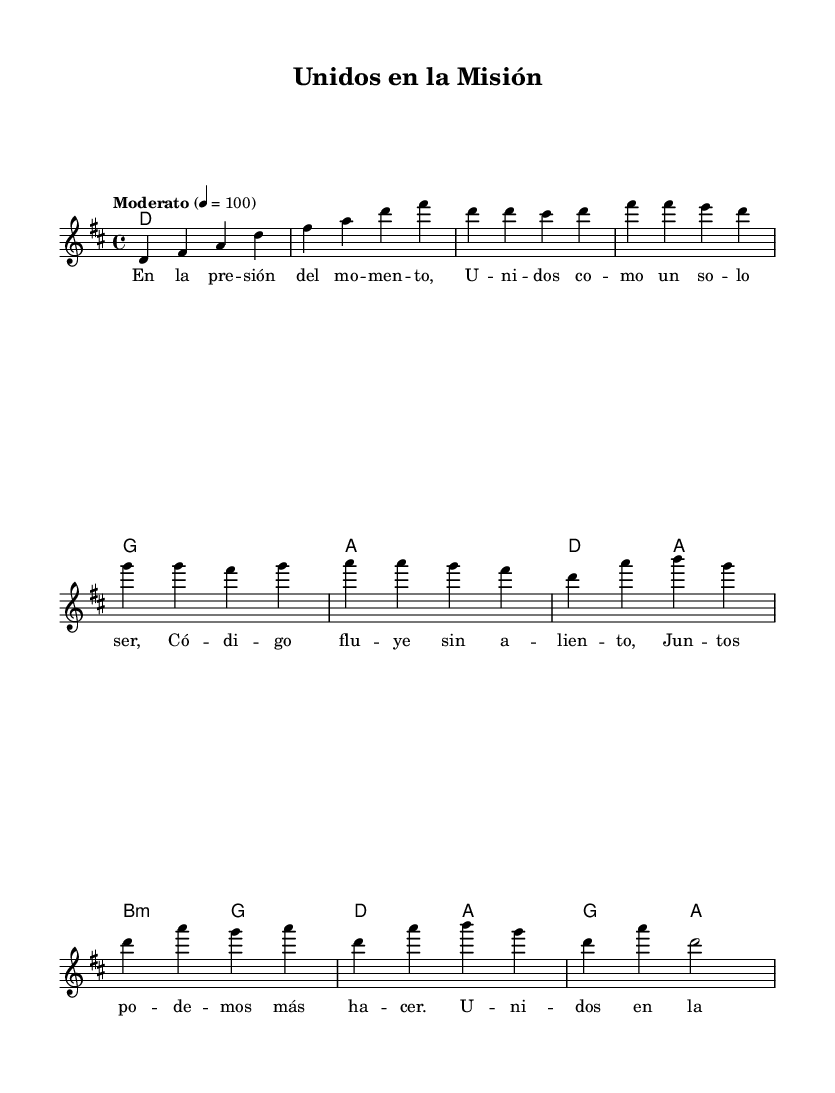What is the key signature of this music? The key signature is indicated by the symbols present at the beginning of the staff. The sheet music shows two sharps, which corresponds to the key of D major.
Answer: D major What is the time signature of this piece? The time signature is visible at the beginning of the sheet music. It shows a 4 over 4 format, indicating that there are four beats in each measure.
Answer: 4/4 What is the tempo marking for this composition? The tempo marking is located above the staff, where it specifies "Moderato" with a metronome marking of 100. This indicates the speed at which the piece should be played.
Answer: Moderato How many verses are there in the lyrics? The lyrics section shows two parts: one labeled as "verseOne" and another labeled as "chorus." This indicates that there is one verse and a chorus.
Answer: One What musical form is used in this piece? Analyzing the structure of the music, there is an identifiable pattern consisting of verses followed by a chorus, commonly known as verse-chorus form. This structure supports the theme of teamwork through repeated messaging.
Answer: Verse-chorus form In which language are the lyrics written? The lyrics can be read at the beginning of the lyric mode section and consist of Spanish words and phrases. This indicates that the song is in Spanish.
Answer: Spanish How does this piece convey themes of teamwork? The lyrics emphasize unity and communication, highlighting collective effort and collaboration, especially noted in phrases like "Unidos en la misión" (United in the mission), suggesting a strong focus on teamwork.
Answer: Unity and collaboration 